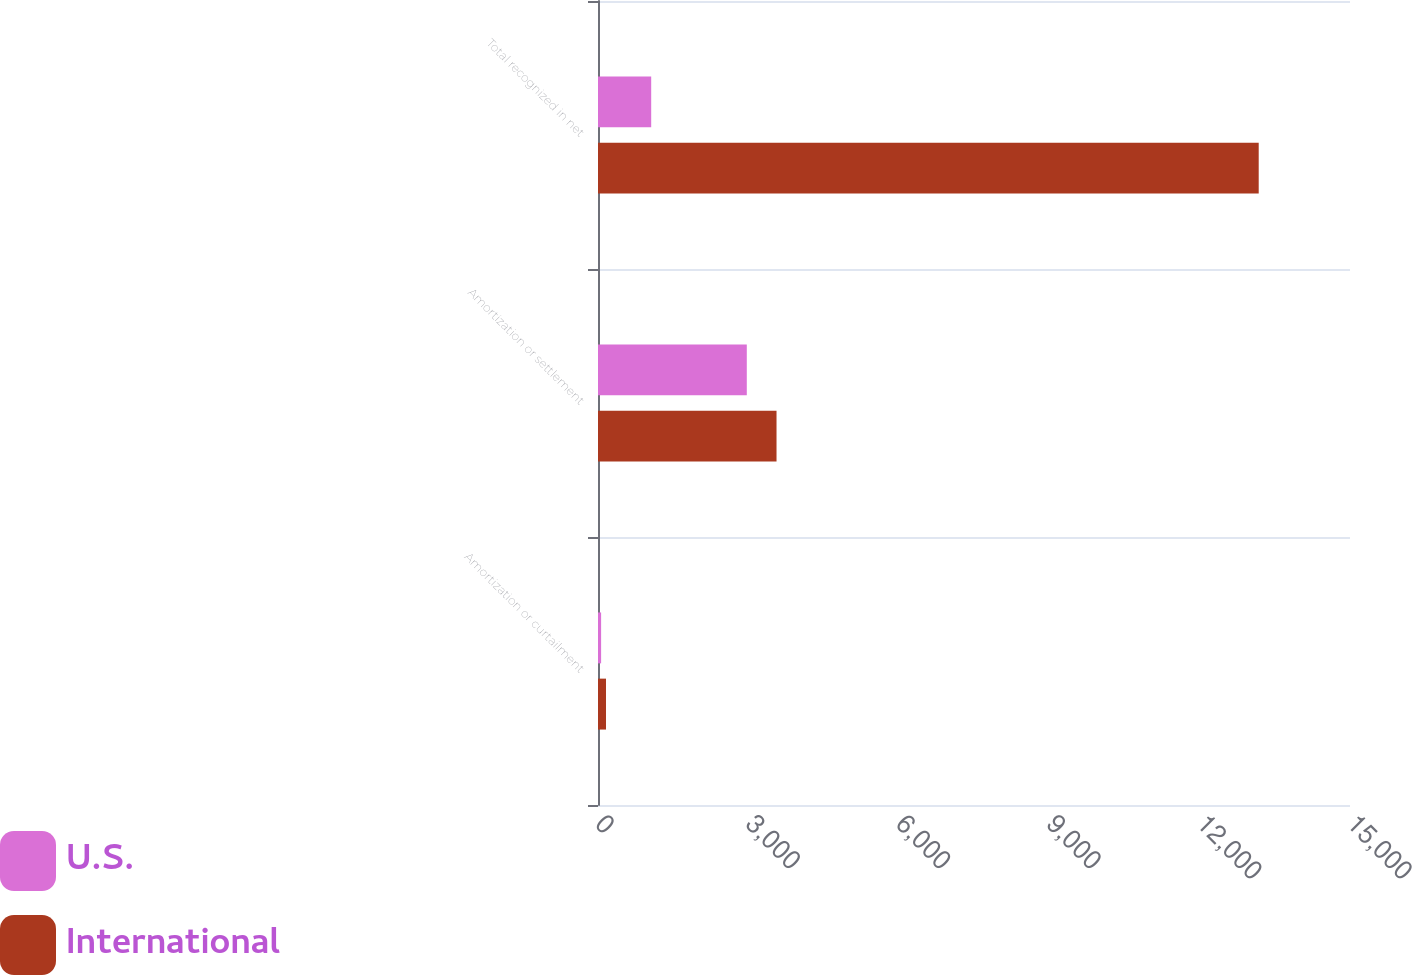<chart> <loc_0><loc_0><loc_500><loc_500><stacked_bar_chart><ecel><fcel>Amortization or curtailment<fcel>Amortization or settlement<fcel>Total recognized in net<nl><fcel>U.S.<fcel>62<fcel>2968<fcel>1061<nl><fcel>International<fcel>160<fcel>3561<fcel>13179<nl></chart> 